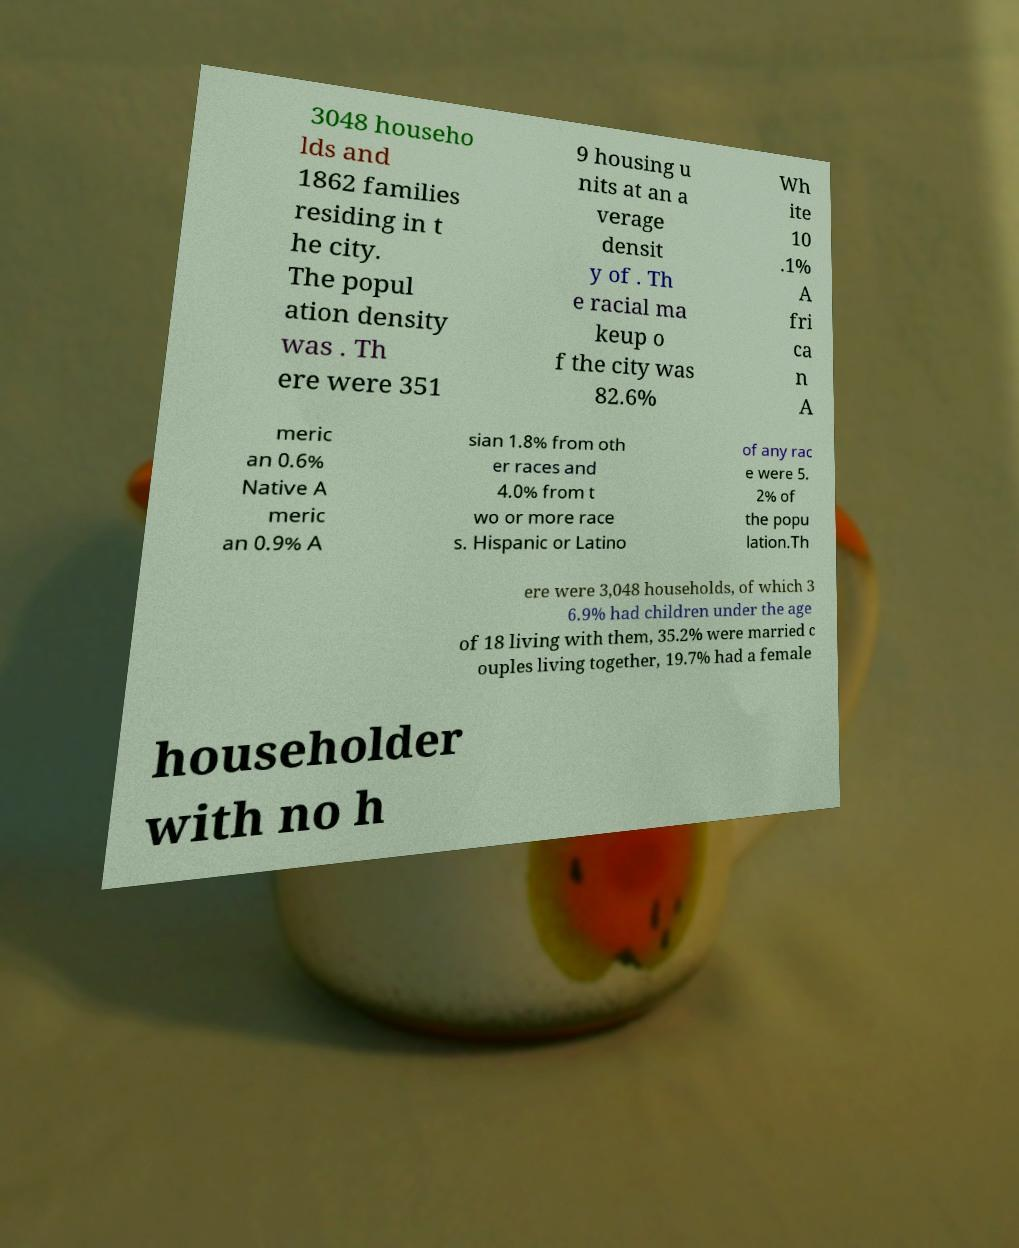Please read and relay the text visible in this image. What does it say? 3048 househo lds and 1862 families residing in t he city. The popul ation density was . Th ere were 351 9 housing u nits at an a verage densit y of . Th e racial ma keup o f the city was 82.6% Wh ite 10 .1% A fri ca n A meric an 0.6% Native A meric an 0.9% A sian 1.8% from oth er races and 4.0% from t wo or more race s. Hispanic or Latino of any rac e were 5. 2% of the popu lation.Th ere were 3,048 households, of which 3 6.9% had children under the age of 18 living with them, 35.2% were married c ouples living together, 19.7% had a female householder with no h 